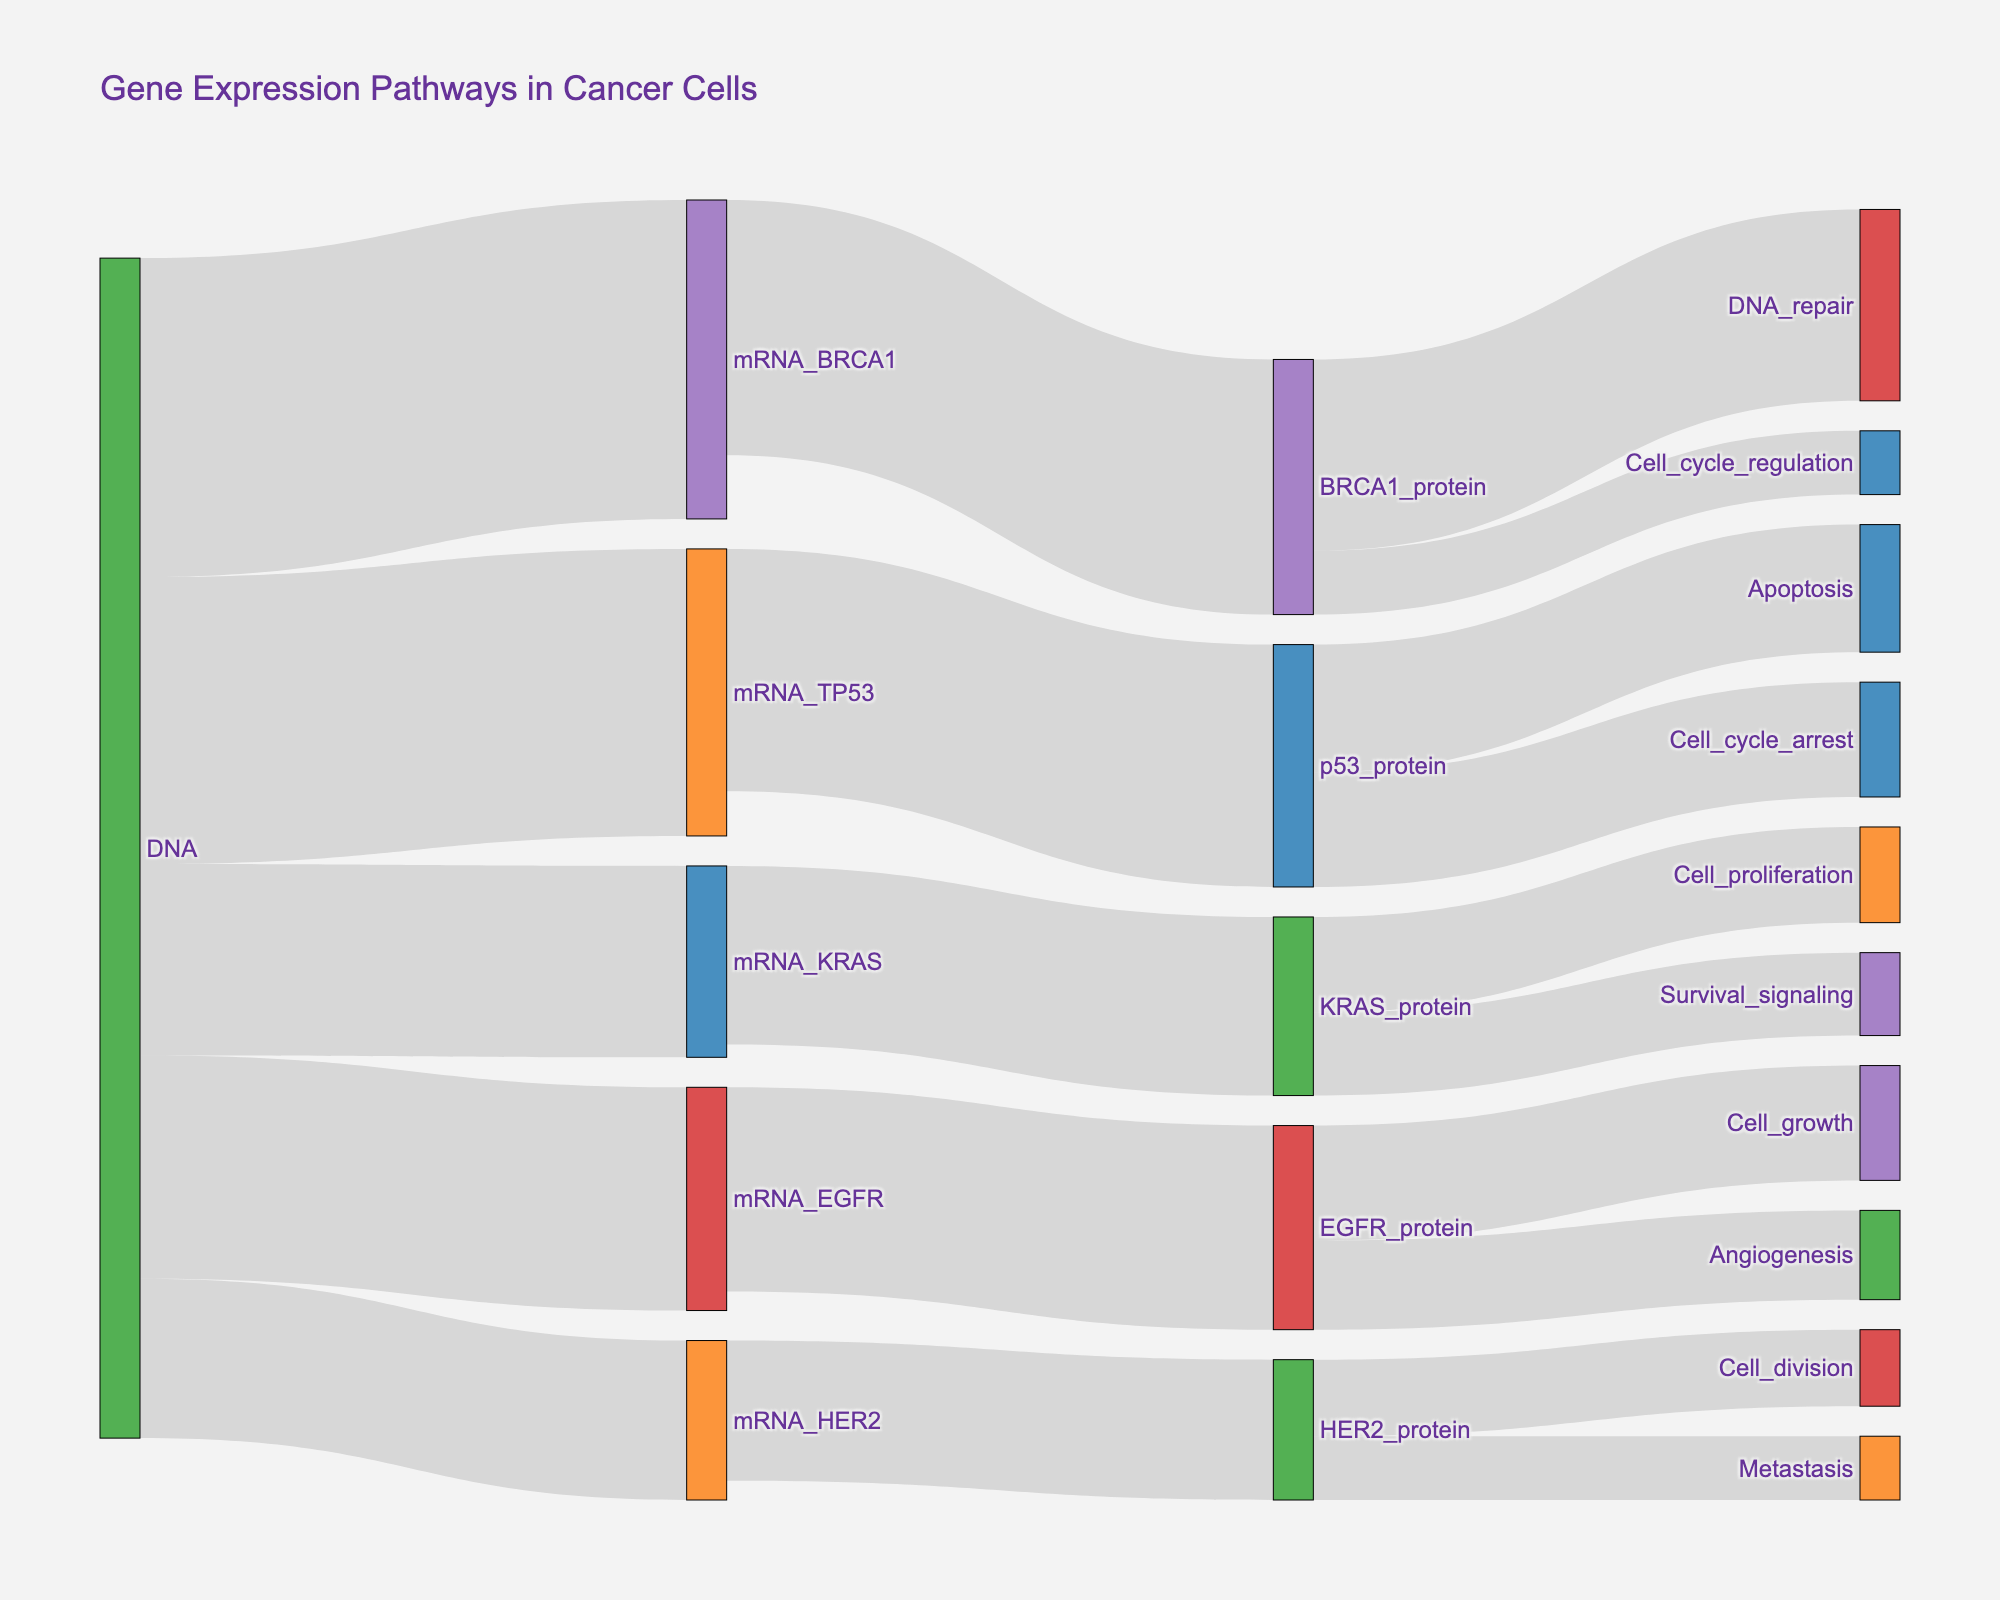What is the title of the Sankey Diagram? The title of the Sankey Diagram is typically displayed prominently at the top of the visualization.
Answer: Gene Expression Pathways in Cancer Cells Which step in the pathway has the highest flow of gene expression from DNA to mRNA? By examining the flow values from the DNA nodes to mRNA nodes, we see that mRNA_BRCA1 has the highest value of 50.
Answer: mRNA_BRCA1 How many total flow units are moving from mRNA_BRCA1 to its respective protein and pathways? The total flow is the sum of the values from mRNA_BRCA1 to BRCA1_protein, and BRCA1_protein to its targets. Adding them gives 40 (to BRCA1_protein), then 30 (to DNA_repair), and 10 (to Cell_cycle_regulation) which results in 40 + 30 + 10 = 80.
Answer: 80 Compare the flows from DNA to mRNA_HER2 and DNA to mRNA_EGFR. Which one has a smaller value? The value from DNA to mRNA_HER2 is 25, and the value from DNA to mRNA_EGFR is 35. Therefore, the value for mRNA_HER2 is smaller.
Answer: mRNA_HER2 Which pathway has the smallest flow value from protein to downstream effects? Look for the smallest value among all the flows from proteins (BRCA1_protein, p53_protein, KRAS_protein, EGFR_protein, HER2_protein) to their targets. The smallest value is 10 from HER2_protein to Metastasis.
Answer: Metastasis What is the difference in flow units between mRNA_KRAS to KRAS_protein and mRNA_HER2 to HER2_protein? The flow from mRNA_KRAS to KRAS_protein is 28 and from mRNA_HER2 to HER2_protein is 22. The difference is 28 - 22 = 6.
Answer: 6 Which protein has the function 'Cell_proliferation' associated with it, and what is its flow value? By tracing the pathways, KRAS_protein is connected to Cell_proliferation with a value of 15.
Answer: KRAS_protein, 15 How many pathways are associated with p53_protein? Count the number of target pathways from p53_protein. There are two: Apoptosis and Cell_cycle_arrest.
Answer: 2 What is the total outflow (sum of flow values) from p53_protein? Add the values from p53_protein to its target pathways: 20 (Apoptosis) + 18 (Cell_cycle_arrest) = 38.
Answer: 38 